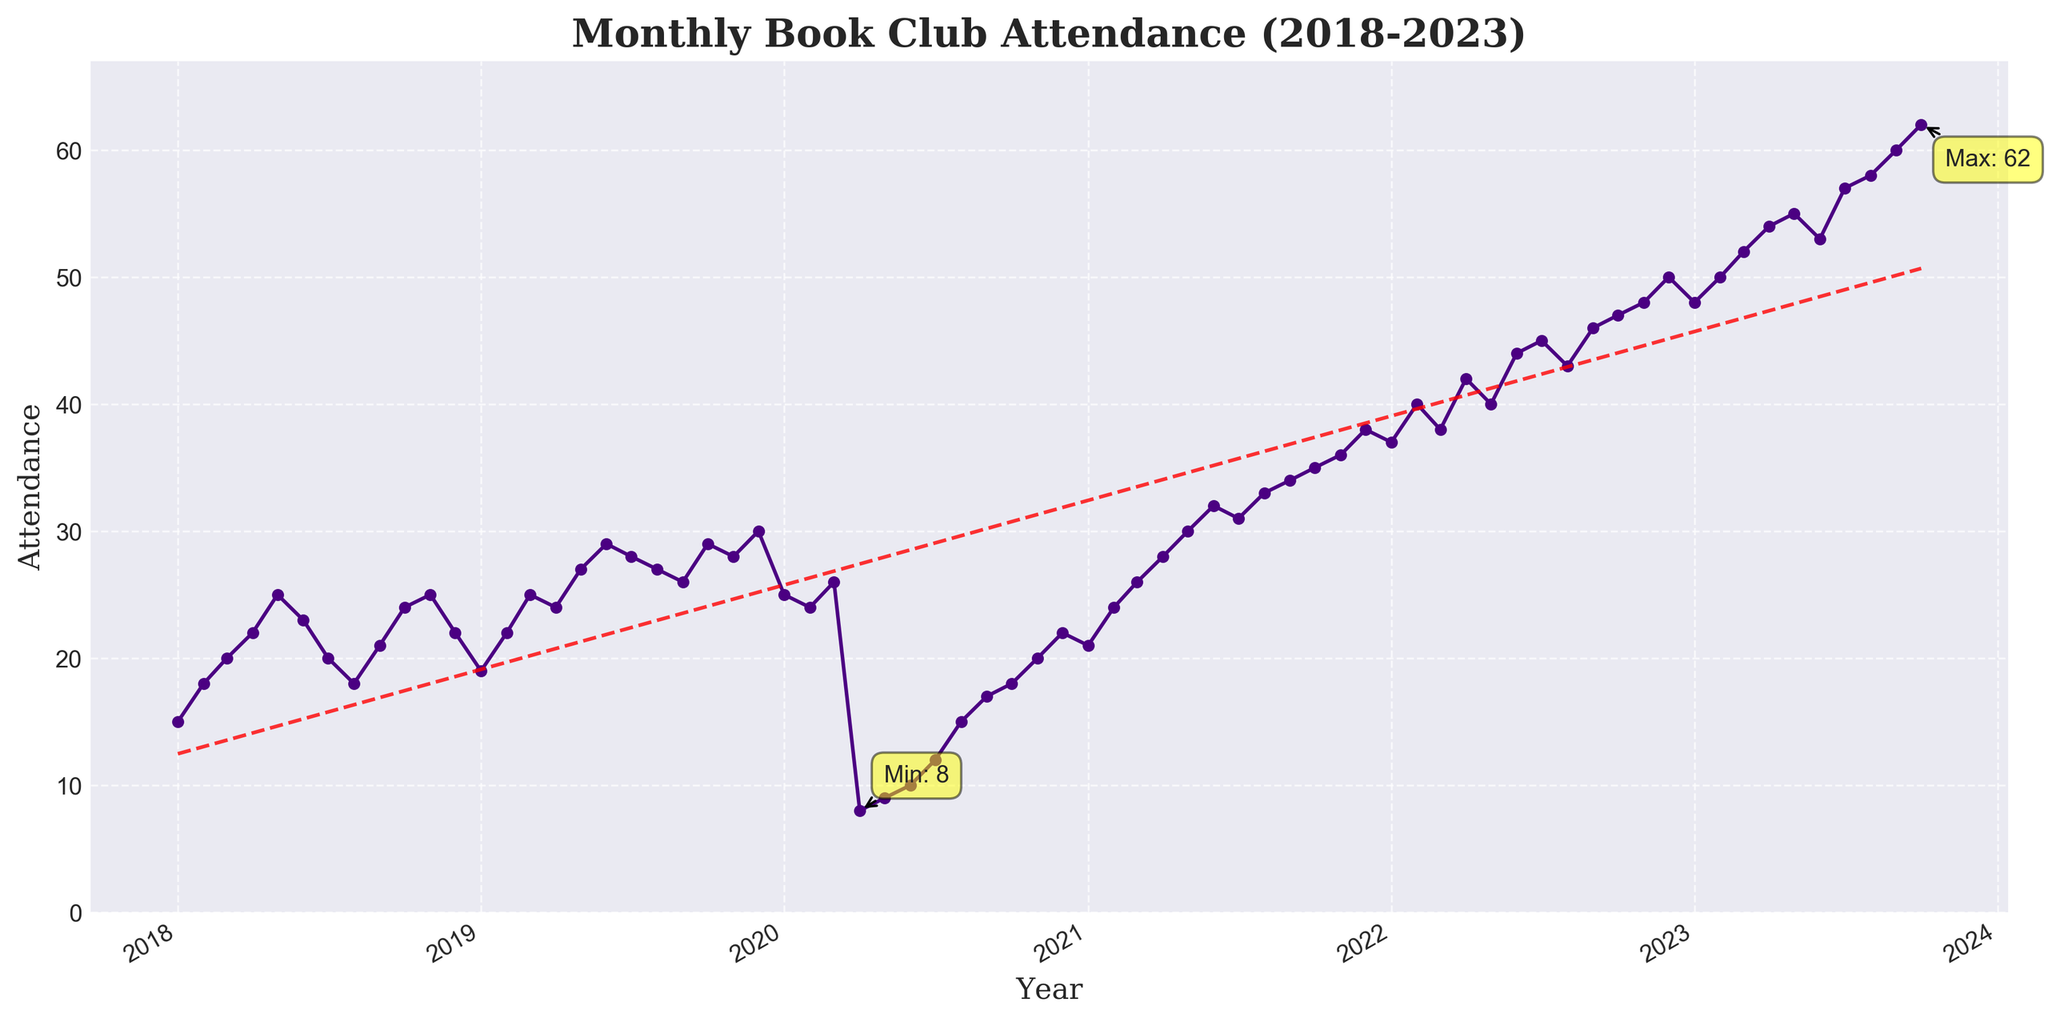When does the highest attendance occur? By inspecting the plot, look for the highest peak and check which month and year it corresponds to.
Answer: October 2023 What is the title of the plot? Read the text at the top of the plot.
Answer: Monthly Book Club Attendance (2018-2023) How many times did attendance go below 10? Identify points on the plot where the attendance value is below 10 and count them.
Answer: 2 What was the attendance in April 2020? Locate April 2020 on the x-axis and see the corresponding y-value.
Answer: 8 Which year shows the biggest increase in attendance from January to December? Compare the attendance values for January and December for each year, then determine the difference for each year and find the maximum difference.
Answer: 2021 What trend can be observed from 2020 to 2023 in terms of attendance? Analyze the slope of the trend line from 2020 to 2023 by looking at the starting point in 2020 and the ending point in 2023.
Answer: Increasing trend Which month and year experienced the lowest attendance? Look for the lowest point on the plot and check the corresponding month and year.
Answer: April 2020 What is the average attendance for the year 2022? Sum the attendance values for each month in 2022 and divide by the number of months (12).
Answer: about 43.08 Did the attendance at any time exceed 50 before 2023? Check all attendance values before 2023 and see if any point surpasses 50.
Answer: No Explain why there is a significant drop in attendance around 2020. Identify the low attendance period and consider possible real-world events that might explain the decline, such as the COVID-19 pandemic.
Answer: Likely due to COVID-19 